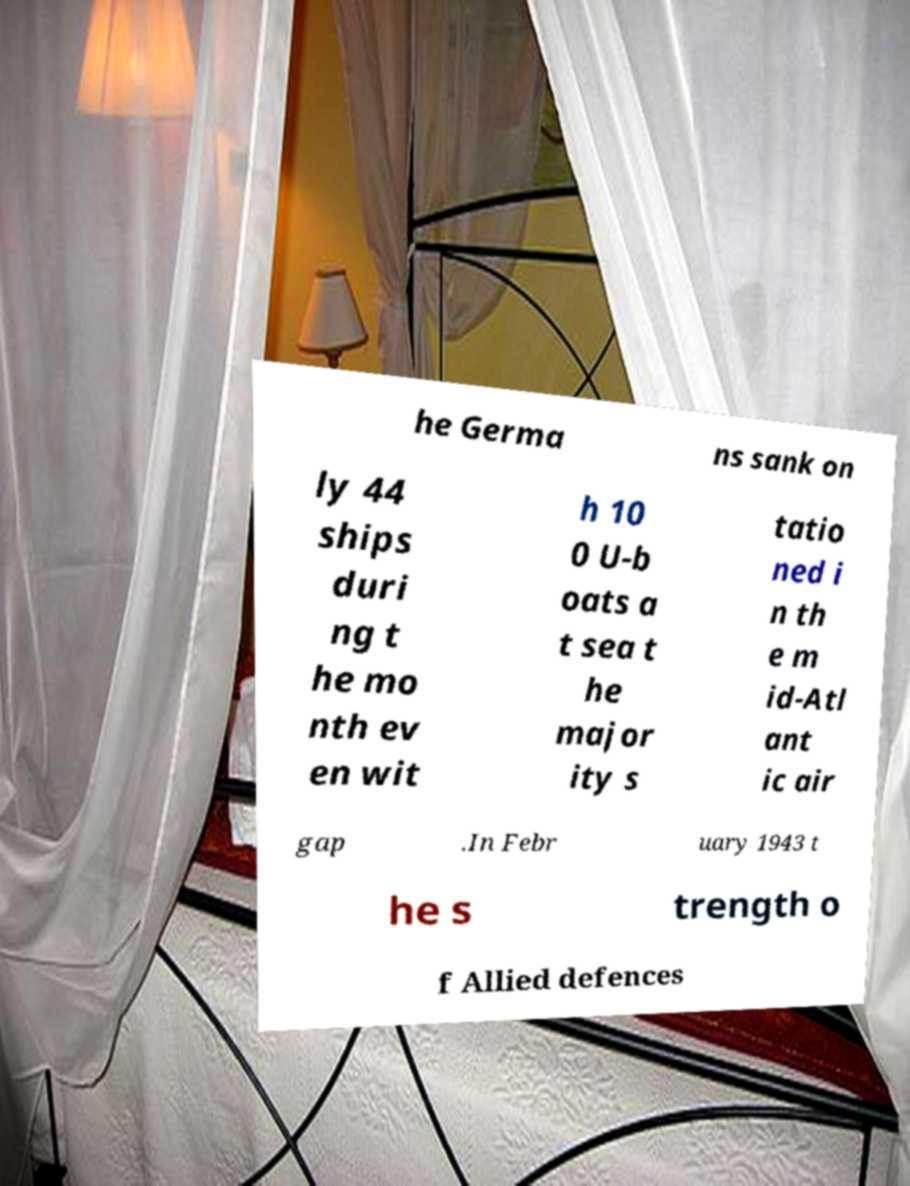Can you accurately transcribe the text from the provided image for me? he Germa ns sank on ly 44 ships duri ng t he mo nth ev en wit h 10 0 U-b oats a t sea t he major ity s tatio ned i n th e m id-Atl ant ic air gap .In Febr uary 1943 t he s trength o f Allied defences 